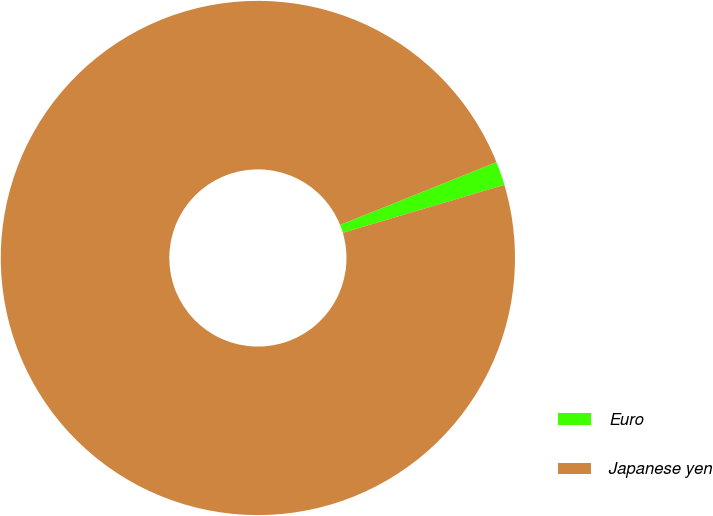Convert chart. <chart><loc_0><loc_0><loc_500><loc_500><pie_chart><fcel>Euro<fcel>Japanese yen<nl><fcel>1.49%<fcel>98.51%<nl></chart> 